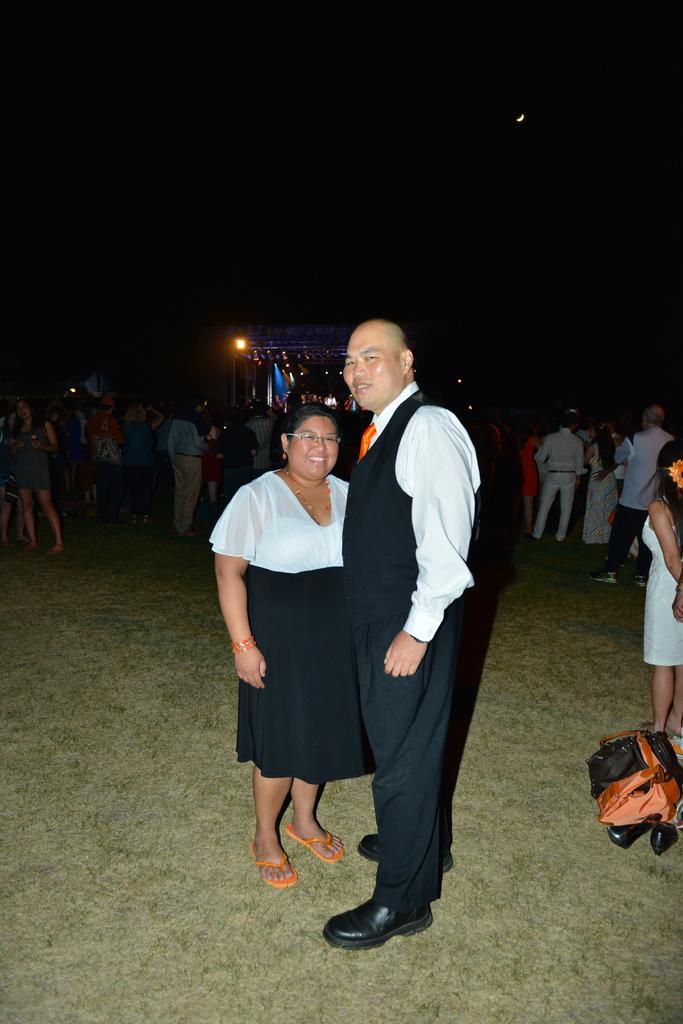In one or two sentences, can you explain what this image depicts? In this image we can see a man and a woman standing. On the right side we can see a bag placed on the ground. On the backside we can see a group of people standing. We can also see a light, the flag and the sky. 